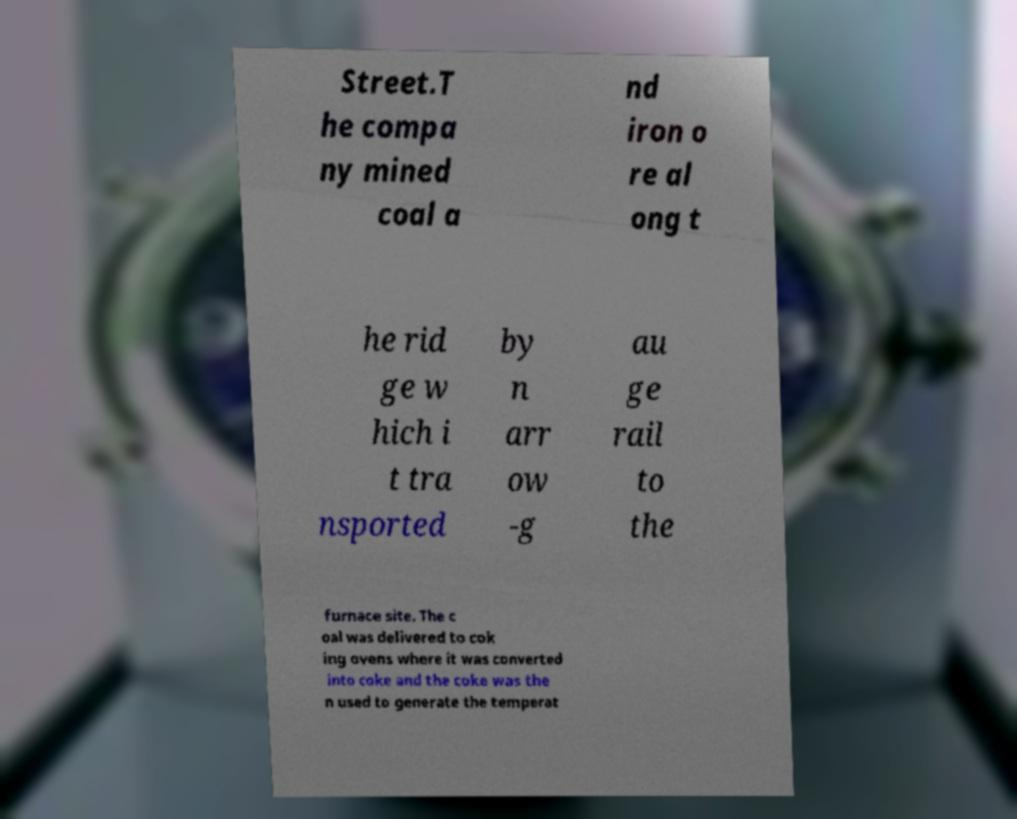I need the written content from this picture converted into text. Can you do that? Street.T he compa ny mined coal a nd iron o re al ong t he rid ge w hich i t tra nsported by n arr ow -g au ge rail to the furnace site. The c oal was delivered to cok ing ovens where it was converted into coke and the coke was the n used to generate the temperat 